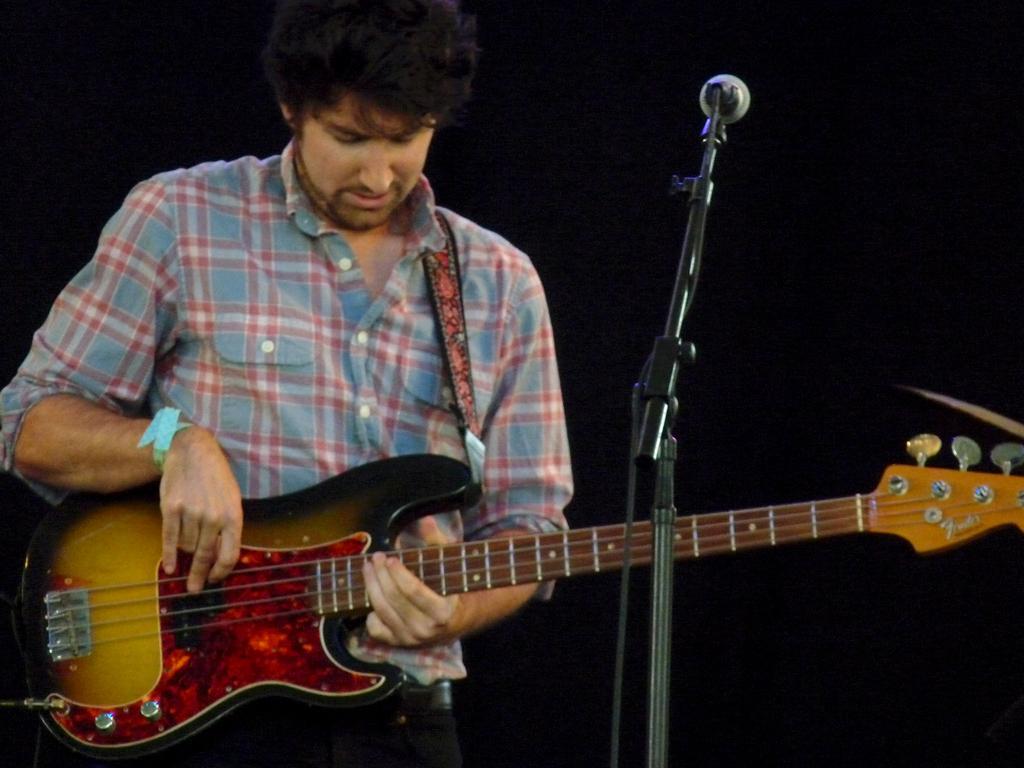Describe this image in one or two sentences. In this picture we can see a man is playing guitar in front of microphone. 